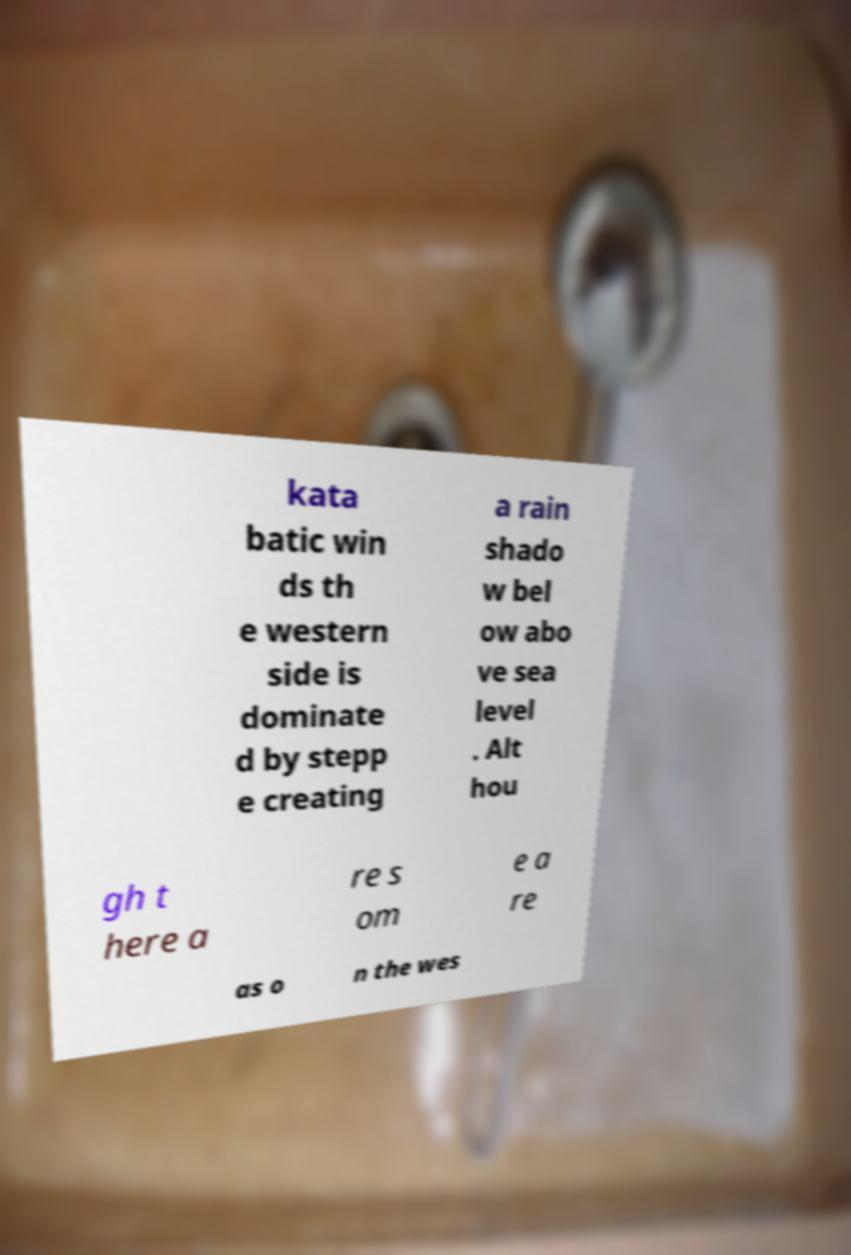Could you assist in decoding the text presented in this image and type it out clearly? kata batic win ds th e western side is dominate d by stepp e creating a rain shado w bel ow abo ve sea level . Alt hou gh t here a re s om e a re as o n the wes 